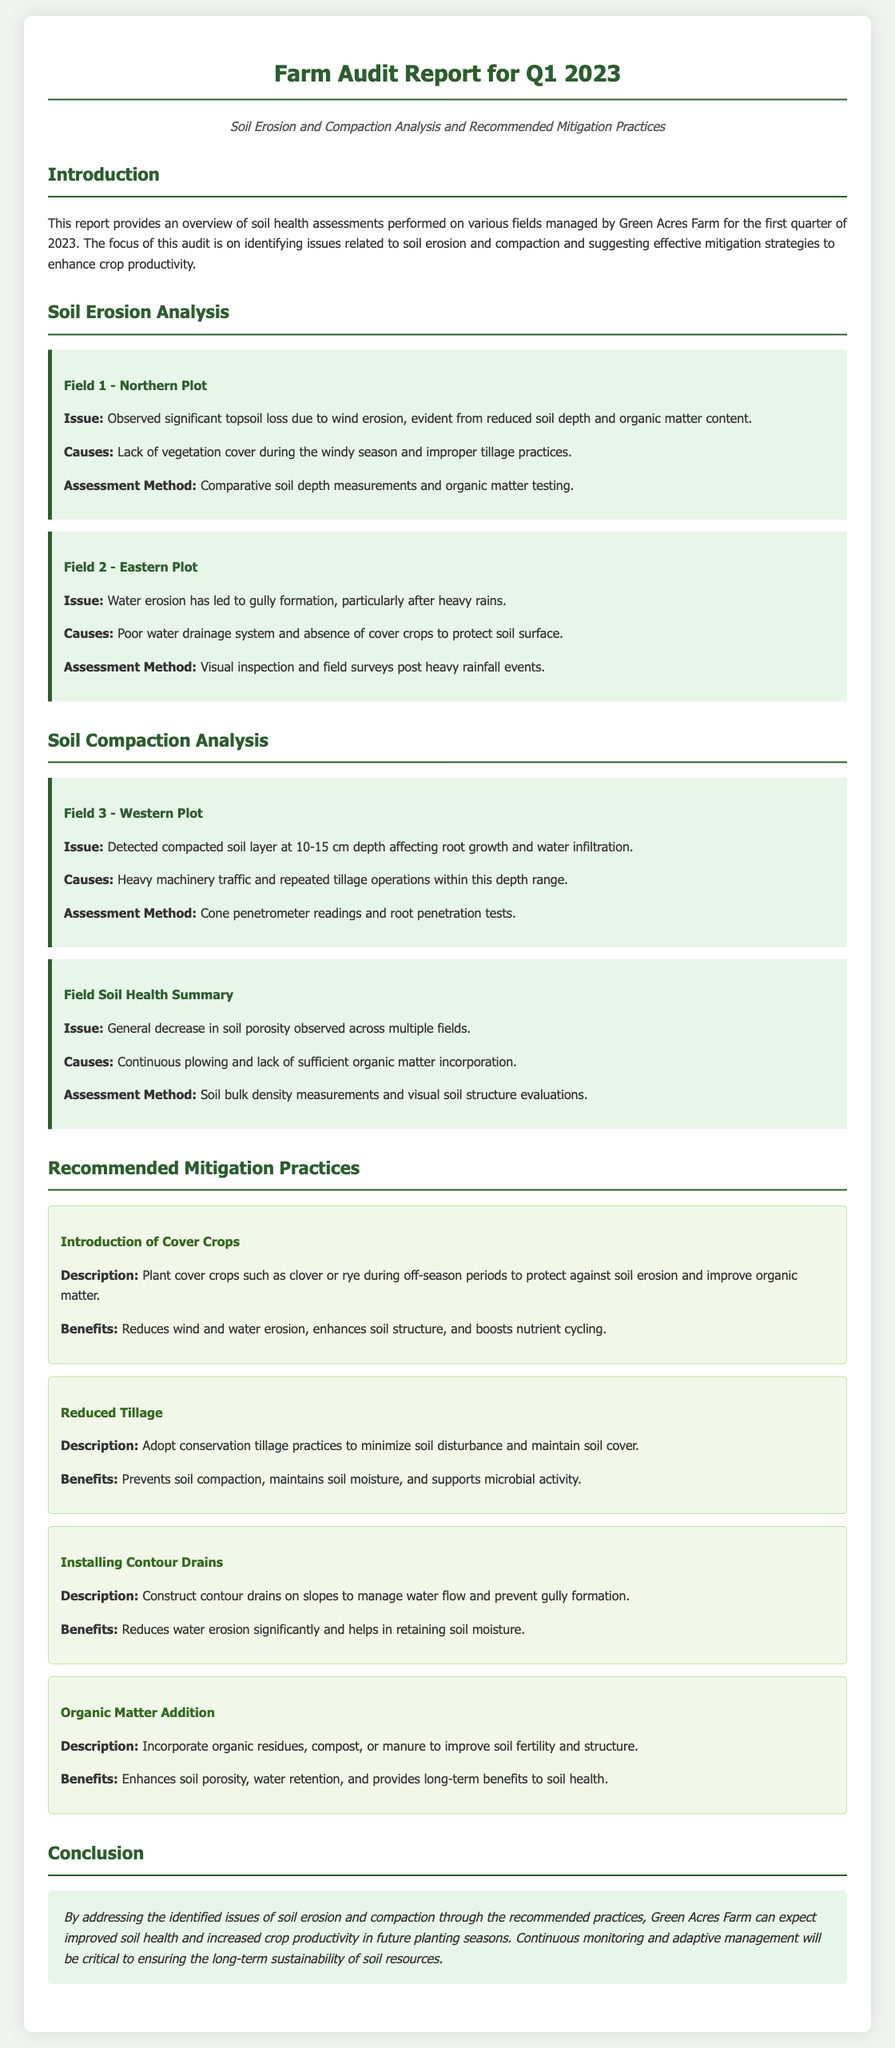What is the title of the report? The title of the report is presented prominently at the top of the document.
Answer: Farm Audit Report for Q1 2023 What key issue was identified in Field 1? The key issue is described in the section detailing soil erosion analysis for Field 1.
Answer: Significant topsoil loss due to wind erosion What is one cause of water erosion in Field 2? The document lists causes specific to each field's erosion issues.
Answer: Poor water drainage system What depth is affected by soil compaction in Field 3? The affected depth is noted when discussing soil compaction issues in Field 3.
Answer: 10-15 cm What is a recommended practice to prevent soil erosion? The document provides several recommended practices to address soil erosion issues.
Answer: Introduction of Cover Crops Which practice enhances soil porosity? The practices are detailed with their benefits; one explicitly improves soil porosity.
Answer: Organic Matter Addition How are issues assessed in the fields? The methods of assessment are explained clearly for each field within the analyses.
Answer: Comparative soil depth measurements What is the conclusion's main expectation for Green Acres Farm? The conclusion summarizes the expected outcome from applying the recommended practices.
Answer: Improved soil health and increased crop productivity What type of audit is this report based on? The introductory section indicates the nature of the report and the audits performed.
Answer: Soil health assessments 